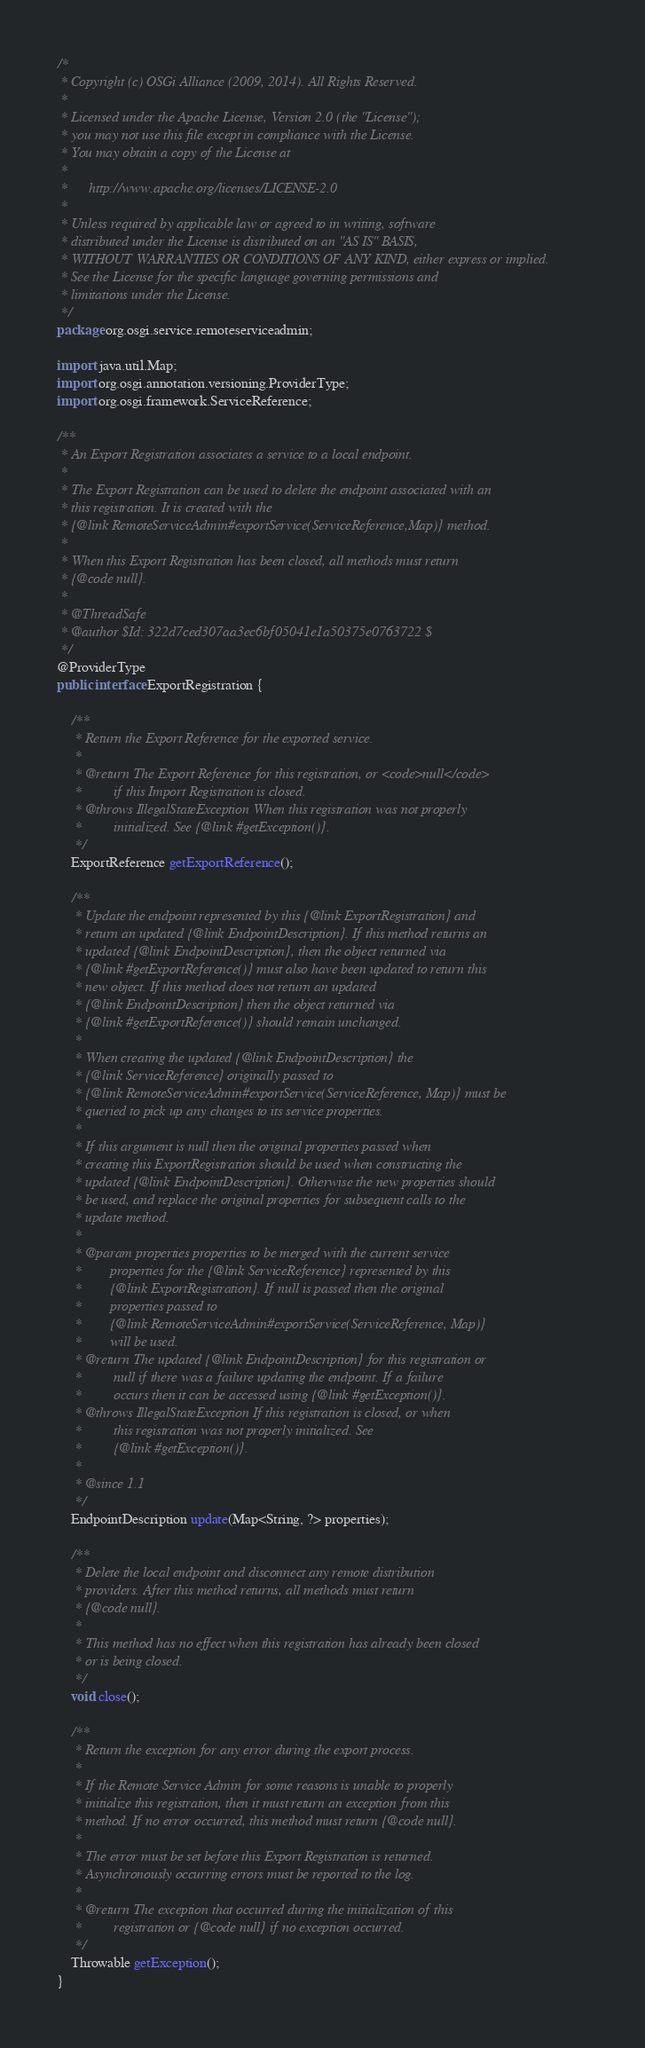<code> <loc_0><loc_0><loc_500><loc_500><_Java_>/*
 * Copyright (c) OSGi Alliance (2009, 2014). All Rights Reserved.
 *
 * Licensed under the Apache License, Version 2.0 (the "License");
 * you may not use this file except in compliance with the License.
 * You may obtain a copy of the License at
 *
 *      http://www.apache.org/licenses/LICENSE-2.0
 *
 * Unless required by applicable law or agreed to in writing, software
 * distributed under the License is distributed on an "AS IS" BASIS,
 * WITHOUT WARRANTIES OR CONDITIONS OF ANY KIND, either express or implied.
 * See the License for the specific language governing permissions and
 * limitations under the License.
 */
package org.osgi.service.remoteserviceadmin;

import java.util.Map;
import org.osgi.annotation.versioning.ProviderType;
import org.osgi.framework.ServiceReference;

/**
 * An Export Registration associates a service to a local endpoint.
 * 
 * The Export Registration can be used to delete the endpoint associated with an
 * this registration. It is created with the
 * {@link RemoteServiceAdmin#exportService(ServiceReference,Map)} method.
 * 
 * When this Export Registration has been closed, all methods must return
 * {@code null}.
 * 
 * @ThreadSafe
 * @author $Id: 322d7ced307aa3ec6bf05041e1a50375e0763722 $
 */
@ProviderType
public interface ExportRegistration {

    /**
	 * Return the Export Reference for the exported service.
	 * 
	 * @return The Export Reference for this registration, or <code>null</code>
	 *         if this Import Registration is closed.
	 * @throws IllegalStateException When this registration was not properly
	 *         initialized. See {@link #getException()}.
	 */
    ExportReference getExportReference();

    /**
	 * Update the endpoint represented by this {@link ExportRegistration} and
	 * return an updated {@link EndpointDescription}. If this method returns an
	 * updated {@link EndpointDescription}, then the object returned via
	 * {@link #getExportReference()} must also have been updated to return this
	 * new object. If this method does not return an updated
	 * {@link EndpointDescription} then the object returned via
	 * {@link #getExportReference()} should remain unchanged.
	 * 
	 * When creating the updated {@link EndpointDescription} the
	 * {@link ServiceReference} originally passed to
	 * {@link RemoteServiceAdmin#exportService(ServiceReference, Map)} must be
	 * queried to pick up any changes to its service properties.
	 * 
	 * If this argument is null then the original properties passed when
	 * creating this ExportRegistration should be used when constructing the
	 * updated {@link EndpointDescription}. Otherwise the new properties should
	 * be used, and replace the original properties for subsequent calls to the
	 * update method.
	 * 
	 * @param properties properties to be merged with the current service
	 *        properties for the {@link ServiceReference} represented by this
	 *        {@link ExportRegistration}. If null is passed then the original
	 *        properties passed to
	 *        {@link RemoteServiceAdmin#exportService(ServiceReference, Map)}
	 *        will be used.
	 * @return The updated {@link EndpointDescription} for this registration or
	 *         null if there was a failure updating the endpoint. If a failure
	 *         occurs then it can be accessed using {@link #getException()}.
	 * @throws IllegalStateException If this registration is closed, or when
	 *         this registration was not properly initialized. See
	 *         {@link #getException()}.
	 * 
	 * @since 1.1
	 */
    EndpointDescription update(Map<String, ?> properties);

    /**
	 * Delete the local endpoint and disconnect any remote distribution
	 * providers. After this method returns, all methods must return
	 * {@code null}.
	 * 
	 * This method has no effect when this registration has already been closed
	 * or is being closed.
	 */
    void close();

    /**
	 * Return the exception for any error during the export process.
	 * 
	 * If the Remote Service Admin for some reasons is unable to properly
	 * initialize this registration, then it must return an exception from this
	 * method. If no error occurred, this method must return {@code null}.
	 * 
	 * The error must be set before this Export Registration is returned.
	 * Asynchronously occurring errors must be reported to the log.
	 * 
	 * @return The exception that occurred during the initialization of this
	 *         registration or {@code null} if no exception occurred.
	 */
    Throwable getException();
}
</code> 